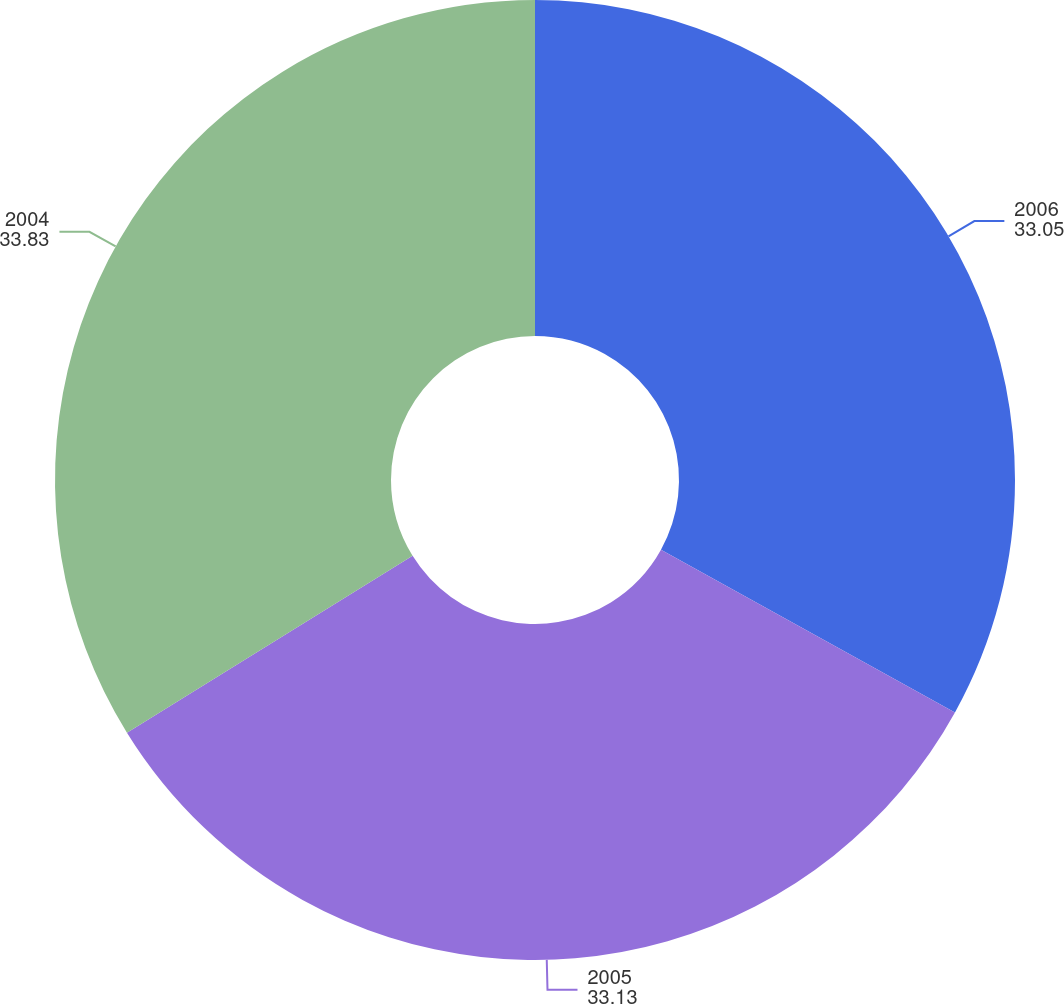Convert chart. <chart><loc_0><loc_0><loc_500><loc_500><pie_chart><fcel>2006<fcel>2005<fcel>2004<nl><fcel>33.05%<fcel>33.13%<fcel>33.83%<nl></chart> 